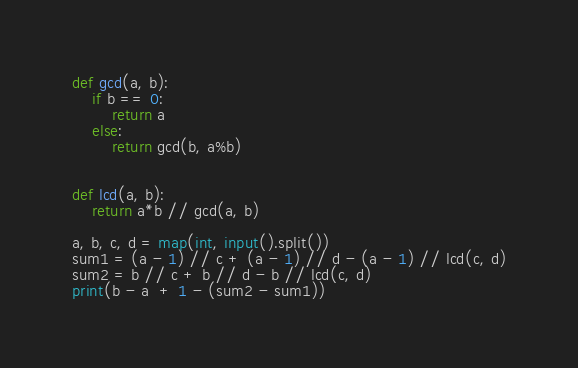Convert code to text. <code><loc_0><loc_0><loc_500><loc_500><_Python_>def gcd(a, b):
    if b == 0:
        return a
    else:
        return gcd(b, a%b)
 
 
def lcd(a, b):
    return a*b // gcd(a, b)
  
a, b, c, d = map(int, input().split())
sum1 = (a - 1) // c + (a - 1) // d - (a - 1) // lcd(c, d)
sum2 = b // c + b // d - b // lcd(c, d)
print(b - a  + 1 - (sum2 - sum1))</code> 